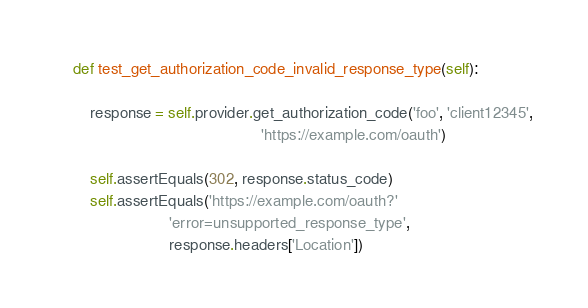<code> <loc_0><loc_0><loc_500><loc_500><_Python_>
    def test_get_authorization_code_invalid_response_type(self):

        response = self.provider.get_authorization_code('foo', 'client12345',
                                               'https://example.com/oauth')

        self.assertEquals(302, response.status_code)
        self.assertEquals('https://example.com/oauth?'
                          'error=unsupported_response_type',
                          response.headers['Location'])
</code> 